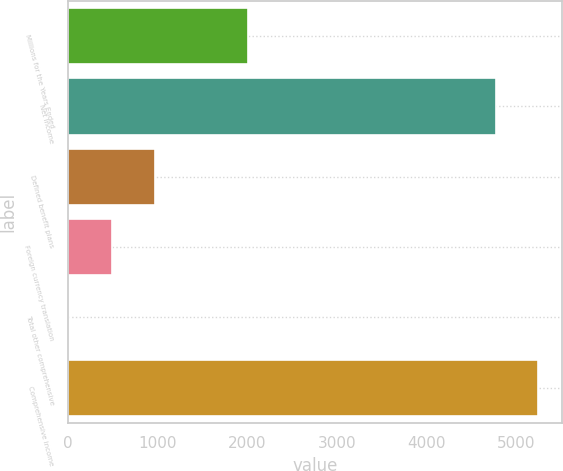Convert chart. <chart><loc_0><loc_0><loc_500><loc_500><bar_chart><fcel>Millions for the Years Ended<fcel>Net income<fcel>Defined benefit plans<fcel>Foreign currency translation<fcel>Total other comprehensive<fcel>Comprehensive income<nl><fcel>2015<fcel>4772<fcel>969.4<fcel>492.2<fcel>15<fcel>5249.2<nl></chart> 